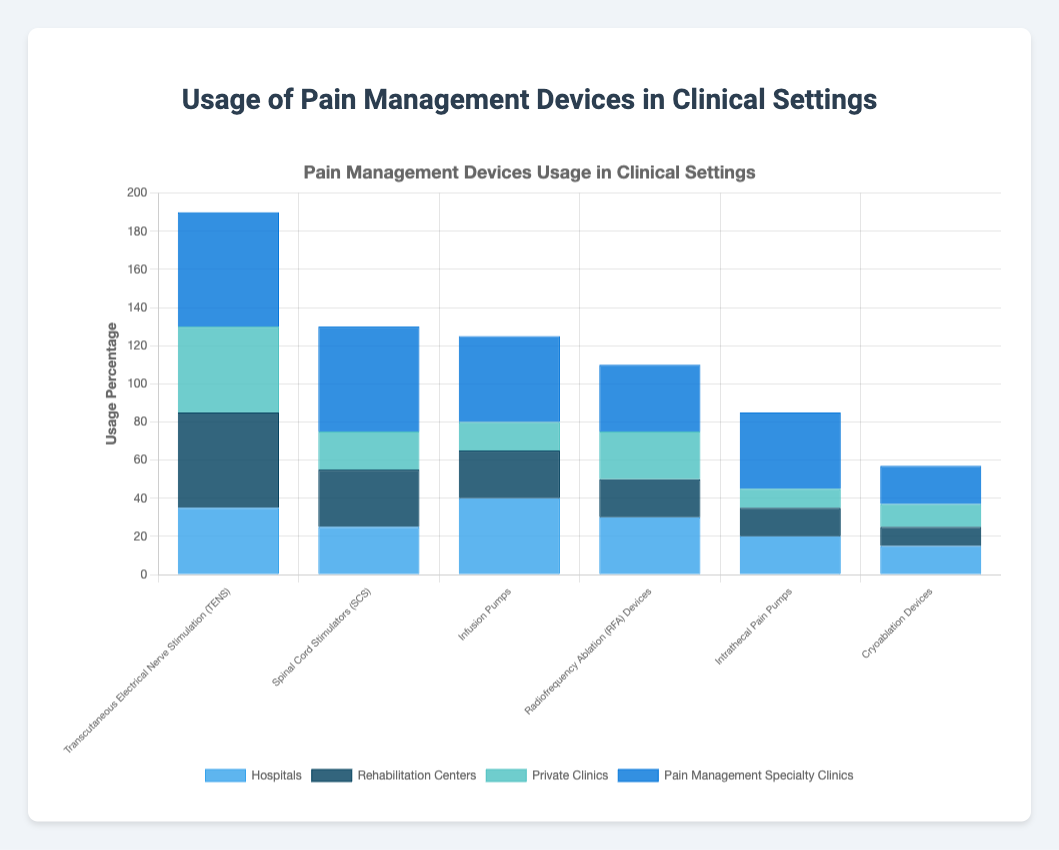Which device is used most frequently in pain management specialty clinics? Look at the bars representing pain management specialty clinics for each device. The highest bar belongs to Transcutaneous Electrical Nerve Stimulation (TENS) with 60% usage.
Answer: Transcutaneous Electrical Nerve Stimulation (TENS) Which clinical setting uses Cryoablation Devices the least? Compare the bars for Cryoablation Devices across all clinical settings. The shortest bar is for rehabilitation centers, indicating the lowest usage at 10%.
Answer: Rehabilitation centers What is the total usage percentage for Infusion Pumps across all clinical settings? Add the usage percentages for Infusion Pumps in hospitals (40%), rehabilitation centers (25%), private clinics (15%), and pain management specialty clinics (45%). The total is 40 + 25 + 15 + 45 = 125%.
Answer: 125% Which device has the smallest difference between its usage in hospitals and private clinics? Calculate the differences for each device: TENS (35-45 = -10%), SCS (25-20 = 5%), Infusion Pumps (40-15 = 25%), RFA (30-25 = 5%), Intrathecal Pain Pumps (20-10 = 10%), Cryoablation Devices (15-12 = 3%). The smallest absolute difference is for Cryoablation Devices (3%).
Answer: Cryoablation Devices Is Spinal Cord Stimulators (SCS) more used in rehabilitation centers or private clinics? Compare the bars for SCS in rehabilitation centers and private clinics. The bar for rehabilitation centers (30%) is higher than that for private clinics (20%).
Answer: Rehabilitation centers Which device is used least frequently overall in all clinical settings? Check the height of the bars across all devices. Cryoablation Devices have the lowest total usage across clinical settings.
Answer: Cryoablation Devices Which clinical setting uses Radiofrequency Ablation (RFA) Devices more than Spinal Cord Stimulators (SCS)? Compare the bars for RFA Devices and SCS in all clinical settings: hospitals (RFA 30% vs SCS 25%), rehabilitation centers (RFA 20% vs SCS 30%), private clinics (RFA 25% vs SCS 20%), pain management specialty clinics (RFA 35% vs SCS 55%). Only hospitals and private clinics use RFA Devices more than SCS.
Answer: Hospitals, Private Clinics What's the combined percentage usage of Intrathecal Pain Pumps in hospitals and pain management specialty clinics? Add the percentages for Intrathecal Pain Pumps in hospitals and pain management specialty clinics: 20% + 40% = 60%.
Answer: 60% Which clinical setting uses Transcutaneous Electrical Nerve Stimulation (TENS) more than 50%? Check the bars for TENS in all clinical settings. The only clinical setting with more than 50% usage is pain management specialty clinics with 60%.
Answer: Pain management specialty clinics 